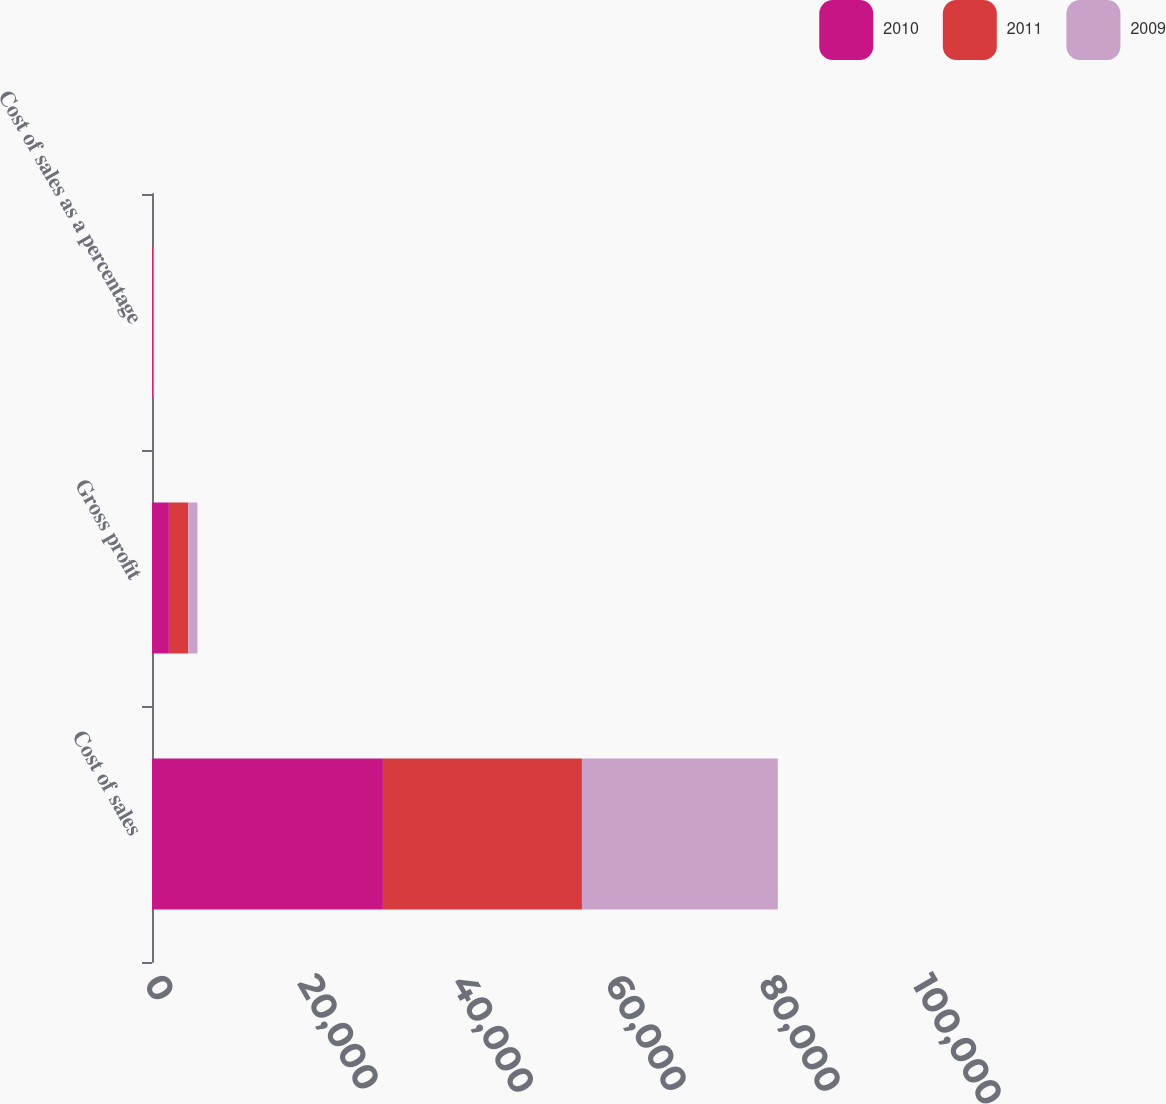<chart> <loc_0><loc_0><loc_500><loc_500><stacked_bar_chart><ecel><fcel>Cost of sales<fcel>Gross profit<fcel>Cost of sales as a percentage<nl><fcel>2010<fcel>30067<fcel>2199<fcel>93.2<nl><fcel>2011<fcel>25916<fcel>2514<fcel>91.2<nl><fcel>2009<fcel>25501<fcel>1203<fcel>95.5<nl></chart> 